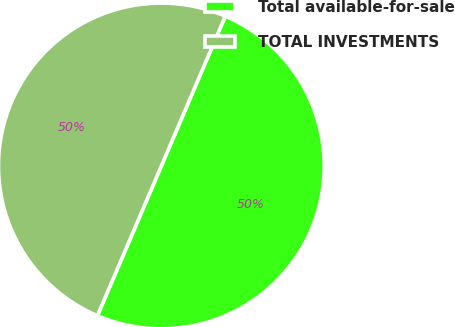Convert chart to OTSL. <chart><loc_0><loc_0><loc_500><loc_500><pie_chart><fcel>Total available-for-sale<fcel>TOTAL INVESTMENTS<nl><fcel>50.0%<fcel>50.0%<nl></chart> 